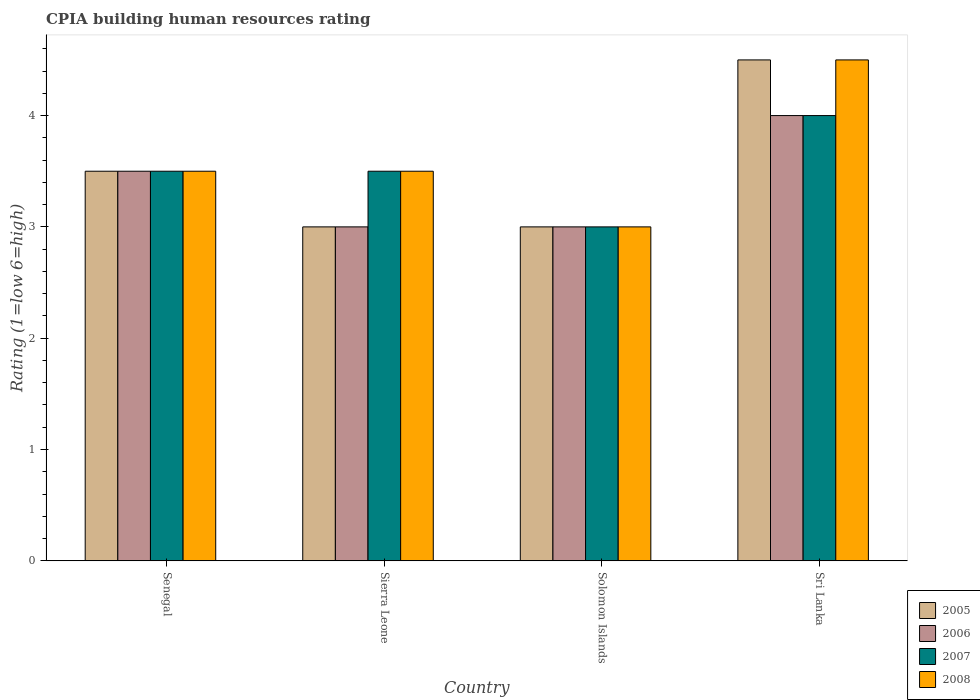How many different coloured bars are there?
Ensure brevity in your answer.  4. How many bars are there on the 2nd tick from the left?
Offer a very short reply. 4. What is the label of the 4th group of bars from the left?
Provide a succinct answer. Sri Lanka. Across all countries, what is the minimum CPIA rating in 2005?
Your answer should be very brief. 3. In which country was the CPIA rating in 2007 maximum?
Your answer should be very brief. Sri Lanka. In which country was the CPIA rating in 2008 minimum?
Give a very brief answer. Solomon Islands. What is the total CPIA rating in 2005 in the graph?
Make the answer very short. 14. What is the difference between the CPIA rating in 2007 in Senegal and that in Sierra Leone?
Your response must be concise. 0. What is the difference between the CPIA rating in 2006 in Sierra Leone and the CPIA rating in 2007 in Sri Lanka?
Make the answer very short. -1. What is the average CPIA rating in 2008 per country?
Your answer should be very brief. 3.62. What is the ratio of the CPIA rating in 2007 in Sierra Leone to that in Solomon Islands?
Offer a very short reply. 1.17. Is the difference between the CPIA rating in 2007 in Sierra Leone and Solomon Islands greater than the difference between the CPIA rating in 2008 in Sierra Leone and Solomon Islands?
Your answer should be very brief. No. What is the difference between the highest and the second highest CPIA rating in 2008?
Offer a very short reply. -1. What is the difference between the highest and the lowest CPIA rating in 2008?
Offer a very short reply. 1.5. What does the 4th bar from the right in Sierra Leone represents?
Your response must be concise. 2005. Are all the bars in the graph horizontal?
Give a very brief answer. No. Does the graph contain any zero values?
Make the answer very short. No. Does the graph contain grids?
Your answer should be very brief. No. Where does the legend appear in the graph?
Offer a very short reply. Bottom right. How many legend labels are there?
Offer a very short reply. 4. How are the legend labels stacked?
Your response must be concise. Vertical. What is the title of the graph?
Ensure brevity in your answer.  CPIA building human resources rating. What is the label or title of the Y-axis?
Offer a very short reply. Rating (1=low 6=high). What is the Rating (1=low 6=high) in 2007 in Senegal?
Ensure brevity in your answer.  3.5. What is the Rating (1=low 6=high) in 2005 in Sierra Leone?
Offer a very short reply. 3. What is the Rating (1=low 6=high) in 2006 in Sierra Leone?
Ensure brevity in your answer.  3. What is the Rating (1=low 6=high) in 2007 in Sierra Leone?
Keep it short and to the point. 3.5. What is the Rating (1=low 6=high) in 2007 in Solomon Islands?
Provide a short and direct response. 3. What is the Rating (1=low 6=high) in 2005 in Sri Lanka?
Keep it short and to the point. 4.5. What is the Rating (1=low 6=high) of 2006 in Sri Lanka?
Your answer should be very brief. 4. What is the Rating (1=low 6=high) of 2008 in Sri Lanka?
Your answer should be compact. 4.5. Across all countries, what is the maximum Rating (1=low 6=high) in 2005?
Your response must be concise. 4.5. Across all countries, what is the maximum Rating (1=low 6=high) in 2006?
Make the answer very short. 4. Across all countries, what is the maximum Rating (1=low 6=high) in 2007?
Offer a very short reply. 4. Across all countries, what is the maximum Rating (1=low 6=high) in 2008?
Provide a succinct answer. 4.5. Across all countries, what is the minimum Rating (1=low 6=high) in 2006?
Your answer should be very brief. 3. What is the total Rating (1=low 6=high) in 2006 in the graph?
Offer a very short reply. 13.5. What is the total Rating (1=low 6=high) in 2008 in the graph?
Your answer should be very brief. 14.5. What is the difference between the Rating (1=low 6=high) in 2007 in Senegal and that in Sierra Leone?
Ensure brevity in your answer.  0. What is the difference between the Rating (1=low 6=high) in 2008 in Senegal and that in Sierra Leone?
Ensure brevity in your answer.  0. What is the difference between the Rating (1=low 6=high) of 2007 in Senegal and that in Solomon Islands?
Provide a succinct answer. 0.5. What is the difference between the Rating (1=low 6=high) in 2008 in Senegal and that in Solomon Islands?
Ensure brevity in your answer.  0.5. What is the difference between the Rating (1=low 6=high) of 2006 in Senegal and that in Sri Lanka?
Keep it short and to the point. -0.5. What is the difference between the Rating (1=low 6=high) of 2008 in Senegal and that in Sri Lanka?
Your response must be concise. -1. What is the difference between the Rating (1=low 6=high) in 2006 in Sierra Leone and that in Solomon Islands?
Offer a terse response. 0. What is the difference between the Rating (1=low 6=high) of 2006 in Sierra Leone and that in Sri Lanka?
Make the answer very short. -1. What is the difference between the Rating (1=low 6=high) of 2008 in Sierra Leone and that in Sri Lanka?
Provide a short and direct response. -1. What is the difference between the Rating (1=low 6=high) in 2008 in Solomon Islands and that in Sri Lanka?
Your response must be concise. -1.5. What is the difference between the Rating (1=low 6=high) of 2005 in Senegal and the Rating (1=low 6=high) of 2006 in Sierra Leone?
Keep it short and to the point. 0.5. What is the difference between the Rating (1=low 6=high) of 2005 in Senegal and the Rating (1=low 6=high) of 2008 in Sierra Leone?
Offer a terse response. 0. What is the difference between the Rating (1=low 6=high) of 2006 in Senegal and the Rating (1=low 6=high) of 2007 in Sierra Leone?
Keep it short and to the point. 0. What is the difference between the Rating (1=low 6=high) in 2007 in Senegal and the Rating (1=low 6=high) in 2008 in Sierra Leone?
Your answer should be compact. 0. What is the difference between the Rating (1=low 6=high) in 2005 in Senegal and the Rating (1=low 6=high) in 2006 in Solomon Islands?
Your response must be concise. 0.5. What is the difference between the Rating (1=low 6=high) in 2005 in Senegal and the Rating (1=low 6=high) in 2007 in Solomon Islands?
Provide a short and direct response. 0.5. What is the difference between the Rating (1=low 6=high) of 2006 in Senegal and the Rating (1=low 6=high) of 2007 in Solomon Islands?
Offer a terse response. 0.5. What is the difference between the Rating (1=low 6=high) of 2007 in Senegal and the Rating (1=low 6=high) of 2008 in Solomon Islands?
Provide a short and direct response. 0.5. What is the difference between the Rating (1=low 6=high) of 2005 in Senegal and the Rating (1=low 6=high) of 2006 in Sri Lanka?
Your response must be concise. -0.5. What is the difference between the Rating (1=low 6=high) in 2005 in Sierra Leone and the Rating (1=low 6=high) in 2007 in Solomon Islands?
Offer a terse response. 0. What is the difference between the Rating (1=low 6=high) of 2005 in Sierra Leone and the Rating (1=low 6=high) of 2008 in Solomon Islands?
Provide a short and direct response. 0. What is the difference between the Rating (1=low 6=high) of 2007 in Sierra Leone and the Rating (1=low 6=high) of 2008 in Solomon Islands?
Your response must be concise. 0.5. What is the difference between the Rating (1=low 6=high) of 2005 in Sierra Leone and the Rating (1=low 6=high) of 2006 in Sri Lanka?
Give a very brief answer. -1. What is the difference between the Rating (1=low 6=high) in 2007 in Solomon Islands and the Rating (1=low 6=high) in 2008 in Sri Lanka?
Provide a short and direct response. -1.5. What is the average Rating (1=low 6=high) of 2006 per country?
Offer a very short reply. 3.38. What is the average Rating (1=low 6=high) in 2008 per country?
Offer a terse response. 3.62. What is the difference between the Rating (1=low 6=high) in 2005 and Rating (1=low 6=high) in 2008 in Senegal?
Offer a terse response. 0. What is the difference between the Rating (1=low 6=high) in 2006 and Rating (1=low 6=high) in 2007 in Senegal?
Ensure brevity in your answer.  0. What is the difference between the Rating (1=low 6=high) of 2006 and Rating (1=low 6=high) of 2008 in Senegal?
Give a very brief answer. 0. What is the difference between the Rating (1=low 6=high) of 2007 and Rating (1=low 6=high) of 2008 in Senegal?
Your answer should be compact. 0. What is the difference between the Rating (1=low 6=high) of 2005 and Rating (1=low 6=high) of 2006 in Sierra Leone?
Your response must be concise. 0. What is the difference between the Rating (1=low 6=high) of 2005 and Rating (1=low 6=high) of 2008 in Sierra Leone?
Keep it short and to the point. -0.5. What is the difference between the Rating (1=low 6=high) of 2006 and Rating (1=low 6=high) of 2008 in Sierra Leone?
Your response must be concise. -0.5. What is the difference between the Rating (1=low 6=high) of 2005 and Rating (1=low 6=high) of 2006 in Solomon Islands?
Your response must be concise. 0. What is the difference between the Rating (1=low 6=high) in 2005 and Rating (1=low 6=high) in 2007 in Solomon Islands?
Your answer should be very brief. 0. What is the difference between the Rating (1=low 6=high) in 2006 and Rating (1=low 6=high) in 2008 in Solomon Islands?
Provide a short and direct response. 0. What is the difference between the Rating (1=low 6=high) of 2007 and Rating (1=low 6=high) of 2008 in Solomon Islands?
Your response must be concise. 0. What is the difference between the Rating (1=low 6=high) of 2005 and Rating (1=low 6=high) of 2006 in Sri Lanka?
Provide a succinct answer. 0.5. What is the difference between the Rating (1=low 6=high) in 2006 and Rating (1=low 6=high) in 2007 in Sri Lanka?
Provide a short and direct response. 0. What is the difference between the Rating (1=low 6=high) of 2006 and Rating (1=low 6=high) of 2008 in Sri Lanka?
Offer a terse response. -0.5. What is the ratio of the Rating (1=low 6=high) of 2005 in Senegal to that in Sierra Leone?
Keep it short and to the point. 1.17. What is the ratio of the Rating (1=low 6=high) of 2006 in Senegal to that in Sierra Leone?
Ensure brevity in your answer.  1.17. What is the ratio of the Rating (1=low 6=high) in 2008 in Senegal to that in Sierra Leone?
Your response must be concise. 1. What is the ratio of the Rating (1=low 6=high) of 2006 in Senegal to that in Solomon Islands?
Offer a terse response. 1.17. What is the ratio of the Rating (1=low 6=high) of 2007 in Senegal to that in Solomon Islands?
Keep it short and to the point. 1.17. What is the ratio of the Rating (1=low 6=high) of 2005 in Senegal to that in Sri Lanka?
Offer a terse response. 0.78. What is the ratio of the Rating (1=low 6=high) of 2007 in Senegal to that in Sri Lanka?
Give a very brief answer. 0.88. What is the ratio of the Rating (1=low 6=high) in 2007 in Sierra Leone to that in Solomon Islands?
Provide a succinct answer. 1.17. What is the ratio of the Rating (1=low 6=high) in 2006 in Sierra Leone to that in Sri Lanka?
Ensure brevity in your answer.  0.75. What is the ratio of the Rating (1=low 6=high) in 2008 in Sierra Leone to that in Sri Lanka?
Offer a terse response. 0.78. What is the ratio of the Rating (1=low 6=high) of 2005 in Solomon Islands to that in Sri Lanka?
Provide a short and direct response. 0.67. What is the ratio of the Rating (1=low 6=high) in 2006 in Solomon Islands to that in Sri Lanka?
Ensure brevity in your answer.  0.75. What is the ratio of the Rating (1=low 6=high) in 2007 in Solomon Islands to that in Sri Lanka?
Your answer should be compact. 0.75. What is the difference between the highest and the second highest Rating (1=low 6=high) of 2005?
Give a very brief answer. 1. What is the difference between the highest and the second highest Rating (1=low 6=high) of 2006?
Make the answer very short. 0.5. What is the difference between the highest and the second highest Rating (1=low 6=high) of 2007?
Offer a terse response. 0.5. What is the difference between the highest and the lowest Rating (1=low 6=high) of 2007?
Your response must be concise. 1. 